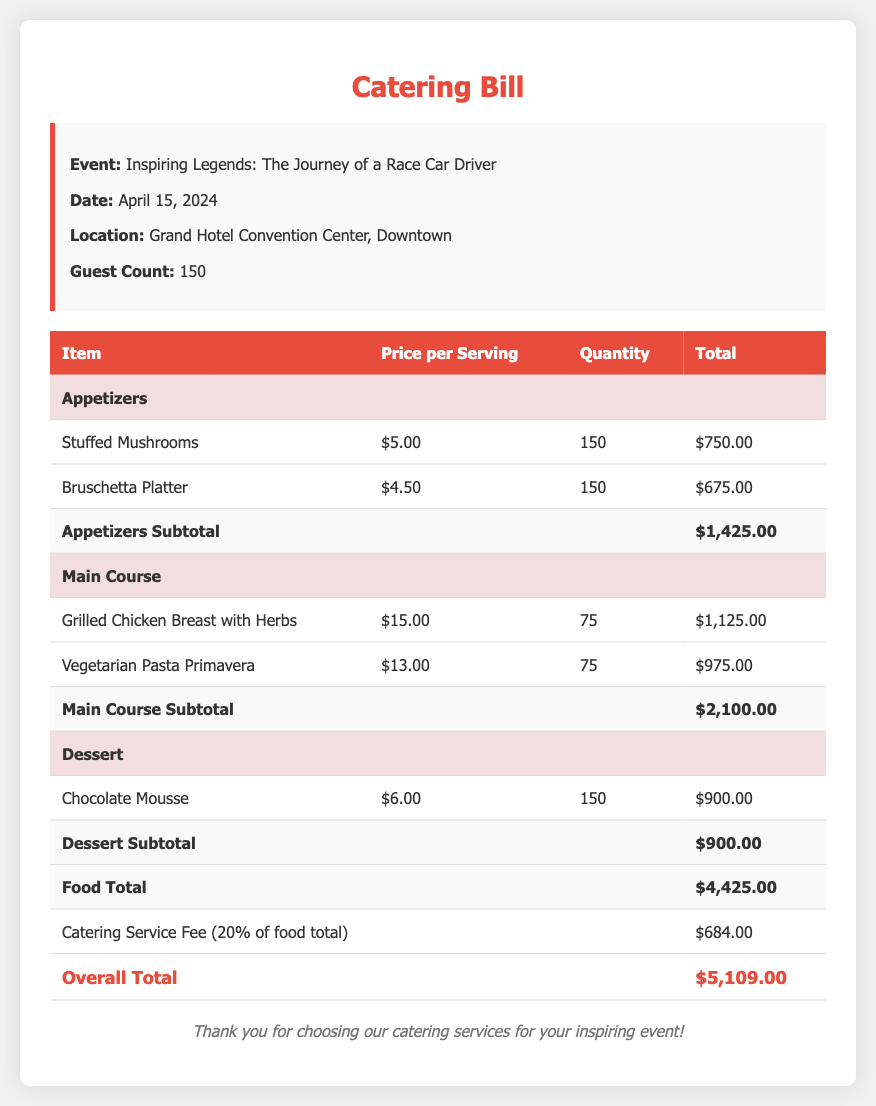What is the event title? The event title is stated clearly at the top of the document, which is "Inspiring Legends: The Journey of a Race Car Driver."
Answer: Inspiring Legends: The Journey of a Race Car Driver What is the guest count? The document mentions the guest count in the event details section, which is 150.
Answer: 150 What is the date of the event? The scheduled date of the event is prominently displayed in the event details section, which is April 15, 2024.
Answer: April 15, 2024 What is the total food cost? The total food cost is provided in the document as the sum of the appetizer, main course, and dessert subtotals, which is $4,425.00.
Answer: $4,425.00 What is the catering service fee percentage? The fee is calculated as 20% of the total food cost, which is specified in the document.
Answer: 20% What is the overall total amount payable? The overall total is found at the end of the cost breakdown, totaling $5,109.00.
Answer: $5,109.00 How many main course items were selected? There are two main course items listed in the breakdown: Grilled Chicken Breast and Vegetarian Pasta Primavera.
Answer: 2 What is the price of the Chocolate Mousse? The price for the Chocolate Mousse, as listed in the dessert section, is $6.00 per serving.
Answer: $6.00 What is the subtotal for appetizers? The subtotal for appetizers is calculated and stated as $1,425.00 in the document.
Answer: $1,425.00 